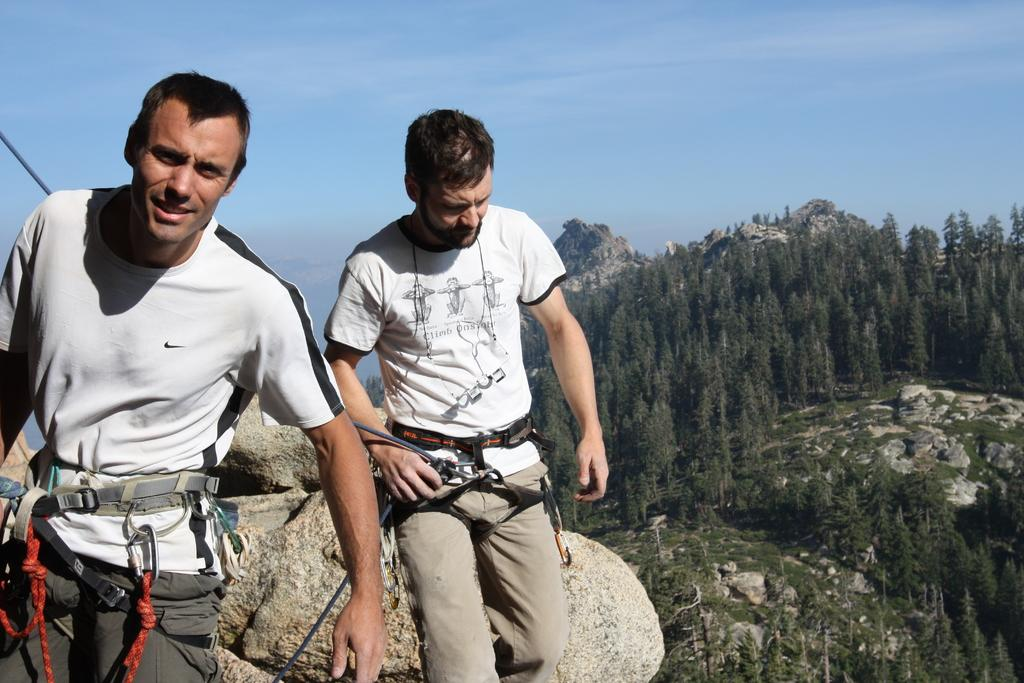How many people are in the image? There are two persons in the image. What are the two persons wearing? Both persons are wearing white t-shirts, pants, and belts. What are the two persons doing in the image? The two persons are standing. What can be seen in the background of the image? There is a huge rock, mountains, trees, and the sky visible in the background of the image. What type of jelly is being used to hold the huge rock in place in the image? There is no jelly present in the image, and the huge rock is not being held in place by any jelly. 